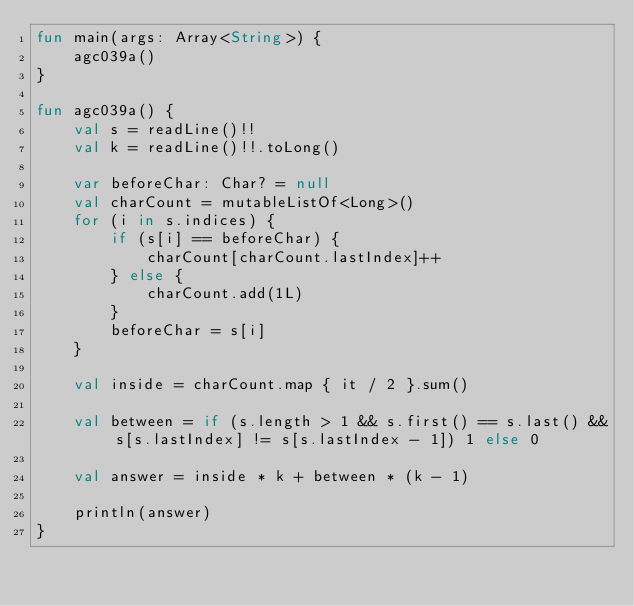Convert code to text. <code><loc_0><loc_0><loc_500><loc_500><_Kotlin_>fun main(args: Array<String>) {
    agc039a()
}

fun agc039a() {
    val s = readLine()!!
    val k = readLine()!!.toLong()

    var beforeChar: Char? = null
    val charCount = mutableListOf<Long>()
    for (i in s.indices) {
        if (s[i] == beforeChar) {
            charCount[charCount.lastIndex]++
        } else {
            charCount.add(1L)
        }
        beforeChar = s[i]
    }

    val inside = charCount.map { it / 2 }.sum()

    val between = if (s.length > 1 && s.first() == s.last() && s[s.lastIndex] != s[s.lastIndex - 1]) 1 else 0

    val answer = inside * k + between * (k - 1)

    println(answer)
}
</code> 